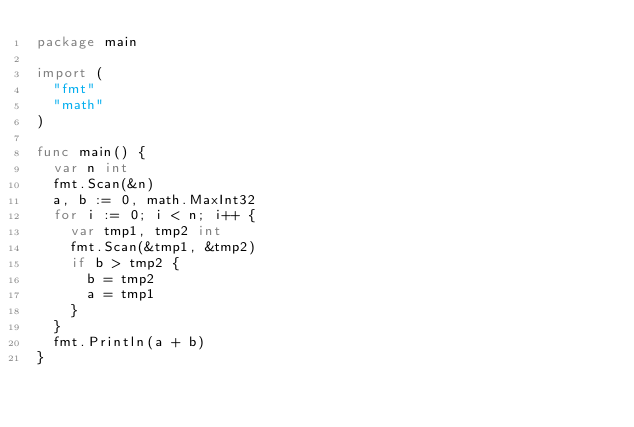<code> <loc_0><loc_0><loc_500><loc_500><_Go_>package main

import (
	"fmt"
	"math"
)

func main() {
	var n int
	fmt.Scan(&n)
	a, b := 0, math.MaxInt32
	for i := 0; i < n; i++ {
		var tmp1, tmp2 int
		fmt.Scan(&tmp1, &tmp2)
		if b > tmp2 {
			b = tmp2
			a = tmp1
		}
	}
	fmt.Println(a + b)
}</code> 